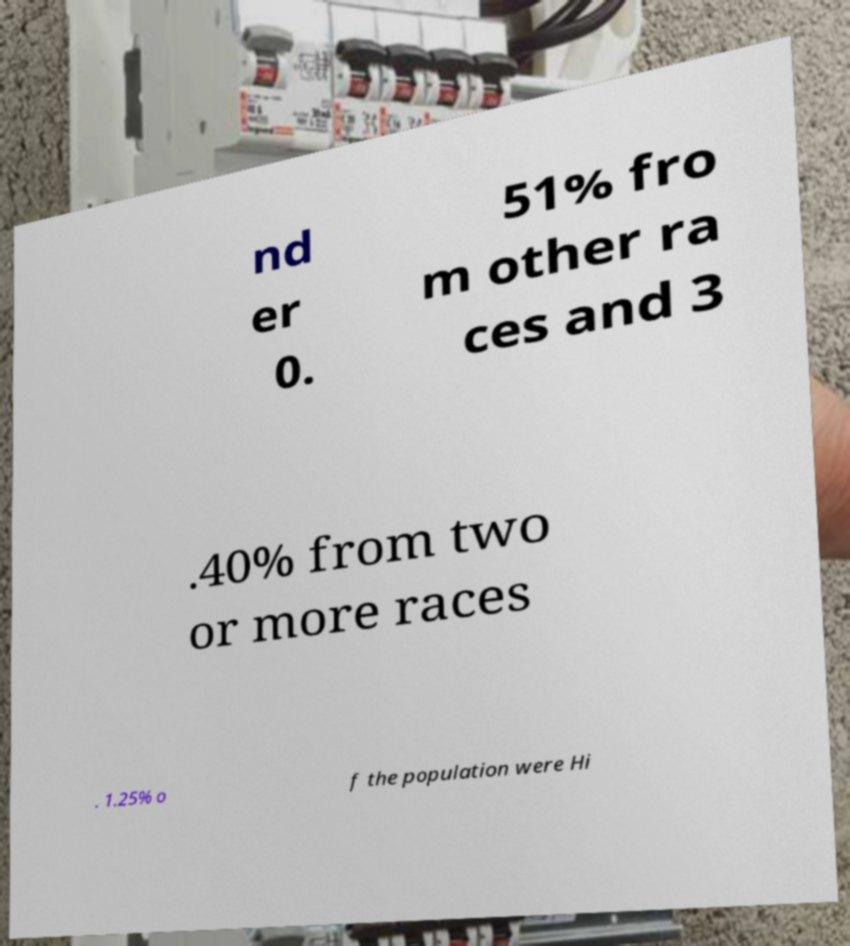For documentation purposes, I need the text within this image transcribed. Could you provide that? nd er 0. 51% fro m other ra ces and 3 .40% from two or more races . 1.25% o f the population were Hi 